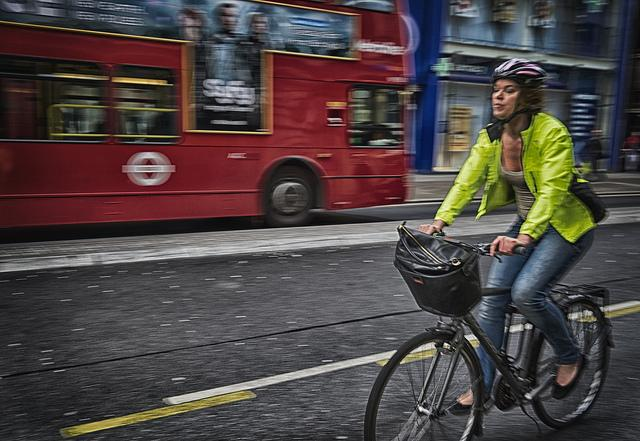What allows the woman on the bike to carry needed items safely?

Choices:
A) zip ties
B) red wagon
C) basket
D) bike rack basket 